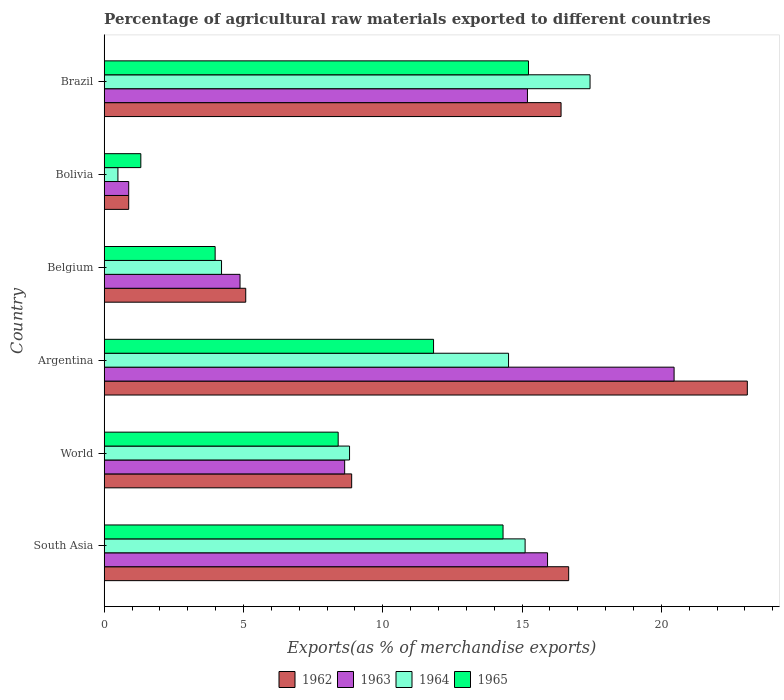How many different coloured bars are there?
Ensure brevity in your answer.  4. Are the number of bars on each tick of the Y-axis equal?
Keep it short and to the point. Yes. How many bars are there on the 6th tick from the top?
Your answer should be very brief. 4. How many bars are there on the 1st tick from the bottom?
Ensure brevity in your answer.  4. What is the label of the 6th group of bars from the top?
Give a very brief answer. South Asia. What is the percentage of exports to different countries in 1964 in World?
Provide a short and direct response. 8.81. Across all countries, what is the maximum percentage of exports to different countries in 1965?
Keep it short and to the point. 15.23. Across all countries, what is the minimum percentage of exports to different countries in 1964?
Offer a very short reply. 0.49. In which country was the percentage of exports to different countries in 1963 minimum?
Your answer should be compact. Bolivia. What is the total percentage of exports to different countries in 1963 in the graph?
Your answer should be compact. 65.96. What is the difference between the percentage of exports to different countries in 1964 in Bolivia and that in World?
Provide a succinct answer. -8.31. What is the difference between the percentage of exports to different countries in 1962 in South Asia and the percentage of exports to different countries in 1964 in Argentina?
Provide a succinct answer. 2.16. What is the average percentage of exports to different countries in 1962 per country?
Give a very brief answer. 11.84. What is the difference between the percentage of exports to different countries in 1963 and percentage of exports to different countries in 1964 in Brazil?
Offer a terse response. -2.25. In how many countries, is the percentage of exports to different countries in 1964 greater than 6 %?
Offer a very short reply. 4. What is the ratio of the percentage of exports to different countries in 1963 in Argentina to that in Bolivia?
Keep it short and to the point. 23.21. Is the difference between the percentage of exports to different countries in 1963 in Argentina and Belgium greater than the difference between the percentage of exports to different countries in 1964 in Argentina and Belgium?
Offer a very short reply. Yes. What is the difference between the highest and the second highest percentage of exports to different countries in 1963?
Provide a short and direct response. 4.54. What is the difference between the highest and the lowest percentage of exports to different countries in 1963?
Your answer should be compact. 19.58. In how many countries, is the percentage of exports to different countries in 1964 greater than the average percentage of exports to different countries in 1964 taken over all countries?
Offer a very short reply. 3. Is the sum of the percentage of exports to different countries in 1962 in Argentina and World greater than the maximum percentage of exports to different countries in 1964 across all countries?
Offer a very short reply. Yes. Is it the case that in every country, the sum of the percentage of exports to different countries in 1962 and percentage of exports to different countries in 1963 is greater than the sum of percentage of exports to different countries in 1964 and percentage of exports to different countries in 1965?
Offer a very short reply. No. What does the 2nd bar from the top in South Asia represents?
Ensure brevity in your answer.  1964. What does the 3rd bar from the bottom in South Asia represents?
Give a very brief answer. 1964. Is it the case that in every country, the sum of the percentage of exports to different countries in 1965 and percentage of exports to different countries in 1964 is greater than the percentage of exports to different countries in 1963?
Keep it short and to the point. Yes. What is the difference between two consecutive major ticks on the X-axis?
Your response must be concise. 5. Does the graph contain any zero values?
Give a very brief answer. No. Does the graph contain grids?
Your answer should be very brief. No. How are the legend labels stacked?
Give a very brief answer. Horizontal. What is the title of the graph?
Make the answer very short. Percentage of agricultural raw materials exported to different countries. What is the label or title of the X-axis?
Your answer should be very brief. Exports(as % of merchandise exports). What is the label or title of the Y-axis?
Provide a short and direct response. Country. What is the Exports(as % of merchandise exports) in 1962 in South Asia?
Provide a succinct answer. 16.67. What is the Exports(as % of merchandise exports) in 1963 in South Asia?
Your answer should be compact. 15.92. What is the Exports(as % of merchandise exports) in 1964 in South Asia?
Your answer should be very brief. 15.11. What is the Exports(as % of merchandise exports) of 1965 in South Asia?
Your answer should be very brief. 14.32. What is the Exports(as % of merchandise exports) of 1962 in World?
Ensure brevity in your answer.  8.89. What is the Exports(as % of merchandise exports) in 1963 in World?
Ensure brevity in your answer.  8.63. What is the Exports(as % of merchandise exports) in 1964 in World?
Ensure brevity in your answer.  8.81. What is the Exports(as % of merchandise exports) in 1965 in World?
Your answer should be compact. 8.4. What is the Exports(as % of merchandise exports) of 1962 in Argentina?
Keep it short and to the point. 23.09. What is the Exports(as % of merchandise exports) of 1963 in Argentina?
Provide a succinct answer. 20.46. What is the Exports(as % of merchandise exports) in 1964 in Argentina?
Provide a short and direct response. 14.52. What is the Exports(as % of merchandise exports) in 1965 in Argentina?
Provide a succinct answer. 11.82. What is the Exports(as % of merchandise exports) of 1962 in Belgium?
Your response must be concise. 5.08. What is the Exports(as % of merchandise exports) of 1963 in Belgium?
Make the answer very short. 4.88. What is the Exports(as % of merchandise exports) in 1964 in Belgium?
Your answer should be very brief. 4.21. What is the Exports(as % of merchandise exports) in 1965 in Belgium?
Your response must be concise. 3.98. What is the Exports(as % of merchandise exports) in 1962 in Bolivia?
Your response must be concise. 0.88. What is the Exports(as % of merchandise exports) of 1963 in Bolivia?
Your answer should be very brief. 0.88. What is the Exports(as % of merchandise exports) of 1964 in Bolivia?
Give a very brief answer. 0.49. What is the Exports(as % of merchandise exports) in 1965 in Bolivia?
Provide a short and direct response. 1.32. What is the Exports(as % of merchandise exports) of 1962 in Brazil?
Make the answer very short. 16.4. What is the Exports(as % of merchandise exports) in 1963 in Brazil?
Give a very brief answer. 15.2. What is the Exports(as % of merchandise exports) in 1964 in Brazil?
Your answer should be compact. 17.44. What is the Exports(as % of merchandise exports) in 1965 in Brazil?
Your answer should be compact. 15.23. Across all countries, what is the maximum Exports(as % of merchandise exports) in 1962?
Ensure brevity in your answer.  23.09. Across all countries, what is the maximum Exports(as % of merchandise exports) in 1963?
Your answer should be compact. 20.46. Across all countries, what is the maximum Exports(as % of merchandise exports) of 1964?
Your answer should be compact. 17.44. Across all countries, what is the maximum Exports(as % of merchandise exports) of 1965?
Your answer should be very brief. 15.23. Across all countries, what is the minimum Exports(as % of merchandise exports) of 1962?
Provide a short and direct response. 0.88. Across all countries, what is the minimum Exports(as % of merchandise exports) in 1963?
Keep it short and to the point. 0.88. Across all countries, what is the minimum Exports(as % of merchandise exports) of 1964?
Provide a succinct answer. 0.49. Across all countries, what is the minimum Exports(as % of merchandise exports) of 1965?
Provide a short and direct response. 1.32. What is the total Exports(as % of merchandise exports) of 1962 in the graph?
Keep it short and to the point. 71.01. What is the total Exports(as % of merchandise exports) in 1963 in the graph?
Give a very brief answer. 65.96. What is the total Exports(as % of merchandise exports) of 1964 in the graph?
Provide a succinct answer. 60.59. What is the total Exports(as % of merchandise exports) in 1965 in the graph?
Your answer should be compact. 55.08. What is the difference between the Exports(as % of merchandise exports) in 1962 in South Asia and that in World?
Your answer should be compact. 7.79. What is the difference between the Exports(as % of merchandise exports) in 1963 in South Asia and that in World?
Make the answer very short. 7.28. What is the difference between the Exports(as % of merchandise exports) in 1964 in South Asia and that in World?
Give a very brief answer. 6.3. What is the difference between the Exports(as % of merchandise exports) of 1965 in South Asia and that in World?
Ensure brevity in your answer.  5.92. What is the difference between the Exports(as % of merchandise exports) in 1962 in South Asia and that in Argentina?
Your answer should be compact. -6.41. What is the difference between the Exports(as % of merchandise exports) of 1963 in South Asia and that in Argentina?
Keep it short and to the point. -4.54. What is the difference between the Exports(as % of merchandise exports) of 1964 in South Asia and that in Argentina?
Offer a very short reply. 0.59. What is the difference between the Exports(as % of merchandise exports) of 1965 in South Asia and that in Argentina?
Keep it short and to the point. 2.49. What is the difference between the Exports(as % of merchandise exports) of 1962 in South Asia and that in Belgium?
Offer a very short reply. 11.59. What is the difference between the Exports(as % of merchandise exports) in 1963 in South Asia and that in Belgium?
Offer a terse response. 11.04. What is the difference between the Exports(as % of merchandise exports) of 1964 in South Asia and that in Belgium?
Offer a very short reply. 10.9. What is the difference between the Exports(as % of merchandise exports) in 1965 in South Asia and that in Belgium?
Offer a terse response. 10.34. What is the difference between the Exports(as % of merchandise exports) of 1962 in South Asia and that in Bolivia?
Your answer should be very brief. 15.79. What is the difference between the Exports(as % of merchandise exports) in 1963 in South Asia and that in Bolivia?
Provide a short and direct response. 15.03. What is the difference between the Exports(as % of merchandise exports) in 1964 in South Asia and that in Bolivia?
Offer a terse response. 14.62. What is the difference between the Exports(as % of merchandise exports) in 1965 in South Asia and that in Bolivia?
Offer a very short reply. 13. What is the difference between the Exports(as % of merchandise exports) in 1962 in South Asia and that in Brazil?
Make the answer very short. 0.27. What is the difference between the Exports(as % of merchandise exports) in 1963 in South Asia and that in Brazil?
Provide a succinct answer. 0.72. What is the difference between the Exports(as % of merchandise exports) of 1964 in South Asia and that in Brazil?
Provide a short and direct response. -2.33. What is the difference between the Exports(as % of merchandise exports) of 1965 in South Asia and that in Brazil?
Your response must be concise. -0.91. What is the difference between the Exports(as % of merchandise exports) in 1962 in World and that in Argentina?
Make the answer very short. -14.2. What is the difference between the Exports(as % of merchandise exports) in 1963 in World and that in Argentina?
Your answer should be very brief. -11.83. What is the difference between the Exports(as % of merchandise exports) in 1964 in World and that in Argentina?
Offer a terse response. -5.71. What is the difference between the Exports(as % of merchandise exports) of 1965 in World and that in Argentina?
Your answer should be compact. -3.42. What is the difference between the Exports(as % of merchandise exports) of 1962 in World and that in Belgium?
Give a very brief answer. 3.8. What is the difference between the Exports(as % of merchandise exports) in 1963 in World and that in Belgium?
Provide a short and direct response. 3.76. What is the difference between the Exports(as % of merchandise exports) of 1964 in World and that in Belgium?
Offer a very short reply. 4.6. What is the difference between the Exports(as % of merchandise exports) in 1965 in World and that in Belgium?
Ensure brevity in your answer.  4.42. What is the difference between the Exports(as % of merchandise exports) of 1962 in World and that in Bolivia?
Your answer should be very brief. 8. What is the difference between the Exports(as % of merchandise exports) in 1963 in World and that in Bolivia?
Your answer should be very brief. 7.75. What is the difference between the Exports(as % of merchandise exports) in 1964 in World and that in Bolivia?
Ensure brevity in your answer.  8.31. What is the difference between the Exports(as % of merchandise exports) of 1965 in World and that in Bolivia?
Offer a very short reply. 7.08. What is the difference between the Exports(as % of merchandise exports) in 1962 in World and that in Brazil?
Provide a short and direct response. -7.52. What is the difference between the Exports(as % of merchandise exports) in 1963 in World and that in Brazil?
Provide a succinct answer. -6.56. What is the difference between the Exports(as % of merchandise exports) of 1964 in World and that in Brazil?
Offer a very short reply. -8.63. What is the difference between the Exports(as % of merchandise exports) in 1965 in World and that in Brazil?
Ensure brevity in your answer.  -6.83. What is the difference between the Exports(as % of merchandise exports) in 1962 in Argentina and that in Belgium?
Provide a short and direct response. 18.01. What is the difference between the Exports(as % of merchandise exports) of 1963 in Argentina and that in Belgium?
Offer a terse response. 15.58. What is the difference between the Exports(as % of merchandise exports) in 1964 in Argentina and that in Belgium?
Your answer should be very brief. 10.3. What is the difference between the Exports(as % of merchandise exports) of 1965 in Argentina and that in Belgium?
Provide a short and direct response. 7.84. What is the difference between the Exports(as % of merchandise exports) in 1962 in Argentina and that in Bolivia?
Your response must be concise. 22.21. What is the difference between the Exports(as % of merchandise exports) of 1963 in Argentina and that in Bolivia?
Offer a very short reply. 19.58. What is the difference between the Exports(as % of merchandise exports) of 1964 in Argentina and that in Bolivia?
Provide a succinct answer. 14.02. What is the difference between the Exports(as % of merchandise exports) of 1965 in Argentina and that in Bolivia?
Give a very brief answer. 10.51. What is the difference between the Exports(as % of merchandise exports) in 1962 in Argentina and that in Brazil?
Make the answer very short. 6.69. What is the difference between the Exports(as % of merchandise exports) in 1963 in Argentina and that in Brazil?
Ensure brevity in your answer.  5.26. What is the difference between the Exports(as % of merchandise exports) in 1964 in Argentina and that in Brazil?
Your answer should be compact. -2.93. What is the difference between the Exports(as % of merchandise exports) in 1965 in Argentina and that in Brazil?
Give a very brief answer. -3.41. What is the difference between the Exports(as % of merchandise exports) of 1962 in Belgium and that in Bolivia?
Provide a short and direct response. 4.2. What is the difference between the Exports(as % of merchandise exports) of 1963 in Belgium and that in Bolivia?
Your response must be concise. 4. What is the difference between the Exports(as % of merchandise exports) in 1964 in Belgium and that in Bolivia?
Your answer should be very brief. 3.72. What is the difference between the Exports(as % of merchandise exports) in 1965 in Belgium and that in Bolivia?
Ensure brevity in your answer.  2.67. What is the difference between the Exports(as % of merchandise exports) in 1962 in Belgium and that in Brazil?
Offer a terse response. -11.32. What is the difference between the Exports(as % of merchandise exports) of 1963 in Belgium and that in Brazil?
Give a very brief answer. -10.32. What is the difference between the Exports(as % of merchandise exports) of 1964 in Belgium and that in Brazil?
Give a very brief answer. -13.23. What is the difference between the Exports(as % of merchandise exports) of 1965 in Belgium and that in Brazil?
Your response must be concise. -11.25. What is the difference between the Exports(as % of merchandise exports) of 1962 in Bolivia and that in Brazil?
Give a very brief answer. -15.52. What is the difference between the Exports(as % of merchandise exports) of 1963 in Bolivia and that in Brazil?
Make the answer very short. -14.31. What is the difference between the Exports(as % of merchandise exports) of 1964 in Bolivia and that in Brazil?
Give a very brief answer. -16.95. What is the difference between the Exports(as % of merchandise exports) in 1965 in Bolivia and that in Brazil?
Provide a short and direct response. -13.92. What is the difference between the Exports(as % of merchandise exports) of 1962 in South Asia and the Exports(as % of merchandise exports) of 1963 in World?
Your answer should be very brief. 8.04. What is the difference between the Exports(as % of merchandise exports) in 1962 in South Asia and the Exports(as % of merchandise exports) in 1964 in World?
Your response must be concise. 7.87. What is the difference between the Exports(as % of merchandise exports) of 1962 in South Asia and the Exports(as % of merchandise exports) of 1965 in World?
Offer a terse response. 8.27. What is the difference between the Exports(as % of merchandise exports) in 1963 in South Asia and the Exports(as % of merchandise exports) in 1964 in World?
Make the answer very short. 7.11. What is the difference between the Exports(as % of merchandise exports) in 1963 in South Asia and the Exports(as % of merchandise exports) in 1965 in World?
Ensure brevity in your answer.  7.52. What is the difference between the Exports(as % of merchandise exports) of 1964 in South Asia and the Exports(as % of merchandise exports) of 1965 in World?
Offer a very short reply. 6.71. What is the difference between the Exports(as % of merchandise exports) of 1962 in South Asia and the Exports(as % of merchandise exports) of 1963 in Argentina?
Provide a succinct answer. -3.78. What is the difference between the Exports(as % of merchandise exports) in 1962 in South Asia and the Exports(as % of merchandise exports) in 1964 in Argentina?
Give a very brief answer. 2.16. What is the difference between the Exports(as % of merchandise exports) of 1962 in South Asia and the Exports(as % of merchandise exports) of 1965 in Argentina?
Offer a very short reply. 4.85. What is the difference between the Exports(as % of merchandise exports) in 1963 in South Asia and the Exports(as % of merchandise exports) in 1964 in Argentina?
Give a very brief answer. 1.4. What is the difference between the Exports(as % of merchandise exports) in 1963 in South Asia and the Exports(as % of merchandise exports) in 1965 in Argentina?
Offer a very short reply. 4.09. What is the difference between the Exports(as % of merchandise exports) in 1964 in South Asia and the Exports(as % of merchandise exports) in 1965 in Argentina?
Your answer should be compact. 3.29. What is the difference between the Exports(as % of merchandise exports) in 1962 in South Asia and the Exports(as % of merchandise exports) in 1963 in Belgium?
Ensure brevity in your answer.  11.8. What is the difference between the Exports(as % of merchandise exports) of 1962 in South Asia and the Exports(as % of merchandise exports) of 1964 in Belgium?
Your answer should be very brief. 12.46. What is the difference between the Exports(as % of merchandise exports) in 1962 in South Asia and the Exports(as % of merchandise exports) in 1965 in Belgium?
Your answer should be compact. 12.69. What is the difference between the Exports(as % of merchandise exports) in 1963 in South Asia and the Exports(as % of merchandise exports) in 1964 in Belgium?
Your answer should be compact. 11.7. What is the difference between the Exports(as % of merchandise exports) in 1963 in South Asia and the Exports(as % of merchandise exports) in 1965 in Belgium?
Offer a terse response. 11.93. What is the difference between the Exports(as % of merchandise exports) of 1964 in South Asia and the Exports(as % of merchandise exports) of 1965 in Belgium?
Offer a very short reply. 11.13. What is the difference between the Exports(as % of merchandise exports) in 1962 in South Asia and the Exports(as % of merchandise exports) in 1963 in Bolivia?
Provide a succinct answer. 15.79. What is the difference between the Exports(as % of merchandise exports) in 1962 in South Asia and the Exports(as % of merchandise exports) in 1964 in Bolivia?
Your answer should be compact. 16.18. What is the difference between the Exports(as % of merchandise exports) in 1962 in South Asia and the Exports(as % of merchandise exports) in 1965 in Bolivia?
Your response must be concise. 15.36. What is the difference between the Exports(as % of merchandise exports) of 1963 in South Asia and the Exports(as % of merchandise exports) of 1964 in Bolivia?
Offer a very short reply. 15.42. What is the difference between the Exports(as % of merchandise exports) of 1963 in South Asia and the Exports(as % of merchandise exports) of 1965 in Bolivia?
Your answer should be very brief. 14.6. What is the difference between the Exports(as % of merchandise exports) in 1964 in South Asia and the Exports(as % of merchandise exports) in 1965 in Bolivia?
Ensure brevity in your answer.  13.79. What is the difference between the Exports(as % of merchandise exports) in 1962 in South Asia and the Exports(as % of merchandise exports) in 1963 in Brazil?
Offer a terse response. 1.48. What is the difference between the Exports(as % of merchandise exports) in 1962 in South Asia and the Exports(as % of merchandise exports) in 1964 in Brazil?
Give a very brief answer. -0.77. What is the difference between the Exports(as % of merchandise exports) of 1962 in South Asia and the Exports(as % of merchandise exports) of 1965 in Brazil?
Your answer should be compact. 1.44. What is the difference between the Exports(as % of merchandise exports) in 1963 in South Asia and the Exports(as % of merchandise exports) in 1964 in Brazil?
Provide a succinct answer. -1.53. What is the difference between the Exports(as % of merchandise exports) of 1963 in South Asia and the Exports(as % of merchandise exports) of 1965 in Brazil?
Keep it short and to the point. 0.68. What is the difference between the Exports(as % of merchandise exports) of 1964 in South Asia and the Exports(as % of merchandise exports) of 1965 in Brazil?
Keep it short and to the point. -0.12. What is the difference between the Exports(as % of merchandise exports) of 1962 in World and the Exports(as % of merchandise exports) of 1963 in Argentina?
Offer a very short reply. -11.57. What is the difference between the Exports(as % of merchandise exports) in 1962 in World and the Exports(as % of merchandise exports) in 1964 in Argentina?
Offer a terse response. -5.63. What is the difference between the Exports(as % of merchandise exports) in 1962 in World and the Exports(as % of merchandise exports) in 1965 in Argentina?
Your answer should be very brief. -2.94. What is the difference between the Exports(as % of merchandise exports) of 1963 in World and the Exports(as % of merchandise exports) of 1964 in Argentina?
Your response must be concise. -5.88. What is the difference between the Exports(as % of merchandise exports) of 1963 in World and the Exports(as % of merchandise exports) of 1965 in Argentina?
Provide a succinct answer. -3.19. What is the difference between the Exports(as % of merchandise exports) of 1964 in World and the Exports(as % of merchandise exports) of 1965 in Argentina?
Your answer should be compact. -3.02. What is the difference between the Exports(as % of merchandise exports) of 1962 in World and the Exports(as % of merchandise exports) of 1963 in Belgium?
Offer a very short reply. 4.01. What is the difference between the Exports(as % of merchandise exports) in 1962 in World and the Exports(as % of merchandise exports) in 1964 in Belgium?
Provide a succinct answer. 4.67. What is the difference between the Exports(as % of merchandise exports) of 1962 in World and the Exports(as % of merchandise exports) of 1965 in Belgium?
Make the answer very short. 4.9. What is the difference between the Exports(as % of merchandise exports) in 1963 in World and the Exports(as % of merchandise exports) in 1964 in Belgium?
Your answer should be very brief. 4.42. What is the difference between the Exports(as % of merchandise exports) in 1963 in World and the Exports(as % of merchandise exports) in 1965 in Belgium?
Give a very brief answer. 4.65. What is the difference between the Exports(as % of merchandise exports) of 1964 in World and the Exports(as % of merchandise exports) of 1965 in Belgium?
Your answer should be compact. 4.82. What is the difference between the Exports(as % of merchandise exports) in 1962 in World and the Exports(as % of merchandise exports) in 1963 in Bolivia?
Provide a short and direct response. 8. What is the difference between the Exports(as % of merchandise exports) in 1962 in World and the Exports(as % of merchandise exports) in 1964 in Bolivia?
Offer a terse response. 8.39. What is the difference between the Exports(as % of merchandise exports) in 1962 in World and the Exports(as % of merchandise exports) in 1965 in Bolivia?
Provide a short and direct response. 7.57. What is the difference between the Exports(as % of merchandise exports) of 1963 in World and the Exports(as % of merchandise exports) of 1964 in Bolivia?
Keep it short and to the point. 8.14. What is the difference between the Exports(as % of merchandise exports) in 1963 in World and the Exports(as % of merchandise exports) in 1965 in Bolivia?
Ensure brevity in your answer.  7.32. What is the difference between the Exports(as % of merchandise exports) of 1964 in World and the Exports(as % of merchandise exports) of 1965 in Bolivia?
Your answer should be very brief. 7.49. What is the difference between the Exports(as % of merchandise exports) in 1962 in World and the Exports(as % of merchandise exports) in 1963 in Brazil?
Make the answer very short. -6.31. What is the difference between the Exports(as % of merchandise exports) in 1962 in World and the Exports(as % of merchandise exports) in 1964 in Brazil?
Your answer should be very brief. -8.56. What is the difference between the Exports(as % of merchandise exports) of 1962 in World and the Exports(as % of merchandise exports) of 1965 in Brazil?
Provide a short and direct response. -6.35. What is the difference between the Exports(as % of merchandise exports) in 1963 in World and the Exports(as % of merchandise exports) in 1964 in Brazil?
Keep it short and to the point. -8.81. What is the difference between the Exports(as % of merchandise exports) in 1963 in World and the Exports(as % of merchandise exports) in 1965 in Brazil?
Keep it short and to the point. -6.6. What is the difference between the Exports(as % of merchandise exports) of 1964 in World and the Exports(as % of merchandise exports) of 1965 in Brazil?
Provide a short and direct response. -6.42. What is the difference between the Exports(as % of merchandise exports) of 1962 in Argentina and the Exports(as % of merchandise exports) of 1963 in Belgium?
Your answer should be compact. 18.21. What is the difference between the Exports(as % of merchandise exports) in 1962 in Argentina and the Exports(as % of merchandise exports) in 1964 in Belgium?
Your answer should be compact. 18.87. What is the difference between the Exports(as % of merchandise exports) of 1962 in Argentina and the Exports(as % of merchandise exports) of 1965 in Belgium?
Offer a very short reply. 19.1. What is the difference between the Exports(as % of merchandise exports) in 1963 in Argentina and the Exports(as % of merchandise exports) in 1964 in Belgium?
Your answer should be compact. 16.25. What is the difference between the Exports(as % of merchandise exports) of 1963 in Argentina and the Exports(as % of merchandise exports) of 1965 in Belgium?
Ensure brevity in your answer.  16.48. What is the difference between the Exports(as % of merchandise exports) of 1964 in Argentina and the Exports(as % of merchandise exports) of 1965 in Belgium?
Keep it short and to the point. 10.53. What is the difference between the Exports(as % of merchandise exports) of 1962 in Argentina and the Exports(as % of merchandise exports) of 1963 in Bolivia?
Give a very brief answer. 22.21. What is the difference between the Exports(as % of merchandise exports) of 1962 in Argentina and the Exports(as % of merchandise exports) of 1964 in Bolivia?
Ensure brevity in your answer.  22.59. What is the difference between the Exports(as % of merchandise exports) in 1962 in Argentina and the Exports(as % of merchandise exports) in 1965 in Bolivia?
Your answer should be compact. 21.77. What is the difference between the Exports(as % of merchandise exports) of 1963 in Argentina and the Exports(as % of merchandise exports) of 1964 in Bolivia?
Give a very brief answer. 19.96. What is the difference between the Exports(as % of merchandise exports) in 1963 in Argentina and the Exports(as % of merchandise exports) in 1965 in Bolivia?
Offer a very short reply. 19.14. What is the difference between the Exports(as % of merchandise exports) of 1964 in Argentina and the Exports(as % of merchandise exports) of 1965 in Bolivia?
Your response must be concise. 13.2. What is the difference between the Exports(as % of merchandise exports) of 1962 in Argentina and the Exports(as % of merchandise exports) of 1963 in Brazil?
Offer a terse response. 7.89. What is the difference between the Exports(as % of merchandise exports) of 1962 in Argentina and the Exports(as % of merchandise exports) of 1964 in Brazil?
Keep it short and to the point. 5.65. What is the difference between the Exports(as % of merchandise exports) in 1962 in Argentina and the Exports(as % of merchandise exports) in 1965 in Brazil?
Give a very brief answer. 7.86. What is the difference between the Exports(as % of merchandise exports) of 1963 in Argentina and the Exports(as % of merchandise exports) of 1964 in Brazil?
Your response must be concise. 3.02. What is the difference between the Exports(as % of merchandise exports) in 1963 in Argentina and the Exports(as % of merchandise exports) in 1965 in Brazil?
Offer a terse response. 5.23. What is the difference between the Exports(as % of merchandise exports) in 1964 in Argentina and the Exports(as % of merchandise exports) in 1965 in Brazil?
Your answer should be compact. -0.72. What is the difference between the Exports(as % of merchandise exports) in 1962 in Belgium and the Exports(as % of merchandise exports) in 1963 in Bolivia?
Ensure brevity in your answer.  4.2. What is the difference between the Exports(as % of merchandise exports) of 1962 in Belgium and the Exports(as % of merchandise exports) of 1964 in Bolivia?
Your answer should be compact. 4.59. What is the difference between the Exports(as % of merchandise exports) in 1962 in Belgium and the Exports(as % of merchandise exports) in 1965 in Bolivia?
Keep it short and to the point. 3.77. What is the difference between the Exports(as % of merchandise exports) of 1963 in Belgium and the Exports(as % of merchandise exports) of 1964 in Bolivia?
Ensure brevity in your answer.  4.38. What is the difference between the Exports(as % of merchandise exports) in 1963 in Belgium and the Exports(as % of merchandise exports) in 1965 in Bolivia?
Keep it short and to the point. 3.56. What is the difference between the Exports(as % of merchandise exports) in 1964 in Belgium and the Exports(as % of merchandise exports) in 1965 in Bolivia?
Offer a very short reply. 2.9. What is the difference between the Exports(as % of merchandise exports) of 1962 in Belgium and the Exports(as % of merchandise exports) of 1963 in Brazil?
Ensure brevity in your answer.  -10.11. What is the difference between the Exports(as % of merchandise exports) in 1962 in Belgium and the Exports(as % of merchandise exports) in 1964 in Brazil?
Provide a succinct answer. -12.36. What is the difference between the Exports(as % of merchandise exports) of 1962 in Belgium and the Exports(as % of merchandise exports) of 1965 in Brazil?
Keep it short and to the point. -10.15. What is the difference between the Exports(as % of merchandise exports) of 1963 in Belgium and the Exports(as % of merchandise exports) of 1964 in Brazil?
Ensure brevity in your answer.  -12.56. What is the difference between the Exports(as % of merchandise exports) in 1963 in Belgium and the Exports(as % of merchandise exports) in 1965 in Brazil?
Make the answer very short. -10.35. What is the difference between the Exports(as % of merchandise exports) in 1964 in Belgium and the Exports(as % of merchandise exports) in 1965 in Brazil?
Provide a succinct answer. -11.02. What is the difference between the Exports(as % of merchandise exports) of 1962 in Bolivia and the Exports(as % of merchandise exports) of 1963 in Brazil?
Make the answer very short. -14.31. What is the difference between the Exports(as % of merchandise exports) in 1962 in Bolivia and the Exports(as % of merchandise exports) in 1964 in Brazil?
Provide a short and direct response. -16.56. What is the difference between the Exports(as % of merchandise exports) of 1962 in Bolivia and the Exports(as % of merchandise exports) of 1965 in Brazil?
Provide a short and direct response. -14.35. What is the difference between the Exports(as % of merchandise exports) of 1963 in Bolivia and the Exports(as % of merchandise exports) of 1964 in Brazil?
Your answer should be compact. -16.56. What is the difference between the Exports(as % of merchandise exports) in 1963 in Bolivia and the Exports(as % of merchandise exports) in 1965 in Brazil?
Offer a terse response. -14.35. What is the difference between the Exports(as % of merchandise exports) of 1964 in Bolivia and the Exports(as % of merchandise exports) of 1965 in Brazil?
Ensure brevity in your answer.  -14.74. What is the average Exports(as % of merchandise exports) of 1962 per country?
Give a very brief answer. 11.84. What is the average Exports(as % of merchandise exports) in 1963 per country?
Your answer should be very brief. 10.99. What is the average Exports(as % of merchandise exports) of 1964 per country?
Offer a terse response. 10.1. What is the average Exports(as % of merchandise exports) in 1965 per country?
Your answer should be very brief. 9.18. What is the difference between the Exports(as % of merchandise exports) of 1962 and Exports(as % of merchandise exports) of 1963 in South Asia?
Ensure brevity in your answer.  0.76. What is the difference between the Exports(as % of merchandise exports) in 1962 and Exports(as % of merchandise exports) in 1964 in South Asia?
Provide a succinct answer. 1.56. What is the difference between the Exports(as % of merchandise exports) in 1962 and Exports(as % of merchandise exports) in 1965 in South Asia?
Give a very brief answer. 2.36. What is the difference between the Exports(as % of merchandise exports) of 1963 and Exports(as % of merchandise exports) of 1964 in South Asia?
Ensure brevity in your answer.  0.81. What is the difference between the Exports(as % of merchandise exports) in 1963 and Exports(as % of merchandise exports) in 1965 in South Asia?
Provide a succinct answer. 1.6. What is the difference between the Exports(as % of merchandise exports) of 1964 and Exports(as % of merchandise exports) of 1965 in South Asia?
Give a very brief answer. 0.79. What is the difference between the Exports(as % of merchandise exports) of 1962 and Exports(as % of merchandise exports) of 1963 in World?
Ensure brevity in your answer.  0.25. What is the difference between the Exports(as % of merchandise exports) of 1962 and Exports(as % of merchandise exports) of 1964 in World?
Keep it short and to the point. 0.08. What is the difference between the Exports(as % of merchandise exports) of 1962 and Exports(as % of merchandise exports) of 1965 in World?
Offer a very short reply. 0.48. What is the difference between the Exports(as % of merchandise exports) in 1963 and Exports(as % of merchandise exports) in 1964 in World?
Your answer should be very brief. -0.18. What is the difference between the Exports(as % of merchandise exports) in 1963 and Exports(as % of merchandise exports) in 1965 in World?
Offer a very short reply. 0.23. What is the difference between the Exports(as % of merchandise exports) of 1964 and Exports(as % of merchandise exports) of 1965 in World?
Your answer should be very brief. 0.41. What is the difference between the Exports(as % of merchandise exports) of 1962 and Exports(as % of merchandise exports) of 1963 in Argentina?
Your answer should be compact. 2.63. What is the difference between the Exports(as % of merchandise exports) of 1962 and Exports(as % of merchandise exports) of 1964 in Argentina?
Give a very brief answer. 8.57. What is the difference between the Exports(as % of merchandise exports) of 1962 and Exports(as % of merchandise exports) of 1965 in Argentina?
Offer a terse response. 11.26. What is the difference between the Exports(as % of merchandise exports) in 1963 and Exports(as % of merchandise exports) in 1964 in Argentina?
Make the answer very short. 5.94. What is the difference between the Exports(as % of merchandise exports) of 1963 and Exports(as % of merchandise exports) of 1965 in Argentina?
Your answer should be compact. 8.63. What is the difference between the Exports(as % of merchandise exports) in 1964 and Exports(as % of merchandise exports) in 1965 in Argentina?
Your answer should be very brief. 2.69. What is the difference between the Exports(as % of merchandise exports) in 1962 and Exports(as % of merchandise exports) in 1963 in Belgium?
Provide a succinct answer. 0.2. What is the difference between the Exports(as % of merchandise exports) of 1962 and Exports(as % of merchandise exports) of 1964 in Belgium?
Ensure brevity in your answer.  0.87. What is the difference between the Exports(as % of merchandise exports) in 1962 and Exports(as % of merchandise exports) in 1965 in Belgium?
Ensure brevity in your answer.  1.1. What is the difference between the Exports(as % of merchandise exports) of 1963 and Exports(as % of merchandise exports) of 1964 in Belgium?
Offer a very short reply. 0.66. What is the difference between the Exports(as % of merchandise exports) of 1963 and Exports(as % of merchandise exports) of 1965 in Belgium?
Keep it short and to the point. 0.89. What is the difference between the Exports(as % of merchandise exports) of 1964 and Exports(as % of merchandise exports) of 1965 in Belgium?
Your answer should be very brief. 0.23. What is the difference between the Exports(as % of merchandise exports) in 1962 and Exports(as % of merchandise exports) in 1963 in Bolivia?
Provide a short and direct response. 0. What is the difference between the Exports(as % of merchandise exports) in 1962 and Exports(as % of merchandise exports) in 1964 in Bolivia?
Give a very brief answer. 0.39. What is the difference between the Exports(as % of merchandise exports) in 1962 and Exports(as % of merchandise exports) in 1965 in Bolivia?
Your answer should be compact. -0.43. What is the difference between the Exports(as % of merchandise exports) in 1963 and Exports(as % of merchandise exports) in 1964 in Bolivia?
Give a very brief answer. 0.39. What is the difference between the Exports(as % of merchandise exports) of 1963 and Exports(as % of merchandise exports) of 1965 in Bolivia?
Offer a very short reply. -0.43. What is the difference between the Exports(as % of merchandise exports) in 1964 and Exports(as % of merchandise exports) in 1965 in Bolivia?
Give a very brief answer. -0.82. What is the difference between the Exports(as % of merchandise exports) of 1962 and Exports(as % of merchandise exports) of 1963 in Brazil?
Your answer should be very brief. 1.21. What is the difference between the Exports(as % of merchandise exports) in 1962 and Exports(as % of merchandise exports) in 1964 in Brazil?
Ensure brevity in your answer.  -1.04. What is the difference between the Exports(as % of merchandise exports) in 1962 and Exports(as % of merchandise exports) in 1965 in Brazil?
Your response must be concise. 1.17. What is the difference between the Exports(as % of merchandise exports) of 1963 and Exports(as % of merchandise exports) of 1964 in Brazil?
Your answer should be compact. -2.25. What is the difference between the Exports(as % of merchandise exports) of 1963 and Exports(as % of merchandise exports) of 1965 in Brazil?
Ensure brevity in your answer.  -0.04. What is the difference between the Exports(as % of merchandise exports) of 1964 and Exports(as % of merchandise exports) of 1965 in Brazil?
Offer a very short reply. 2.21. What is the ratio of the Exports(as % of merchandise exports) in 1962 in South Asia to that in World?
Your answer should be very brief. 1.88. What is the ratio of the Exports(as % of merchandise exports) in 1963 in South Asia to that in World?
Provide a succinct answer. 1.84. What is the ratio of the Exports(as % of merchandise exports) of 1964 in South Asia to that in World?
Offer a terse response. 1.72. What is the ratio of the Exports(as % of merchandise exports) in 1965 in South Asia to that in World?
Keep it short and to the point. 1.7. What is the ratio of the Exports(as % of merchandise exports) in 1962 in South Asia to that in Argentina?
Your response must be concise. 0.72. What is the ratio of the Exports(as % of merchandise exports) of 1963 in South Asia to that in Argentina?
Make the answer very short. 0.78. What is the ratio of the Exports(as % of merchandise exports) in 1964 in South Asia to that in Argentina?
Keep it short and to the point. 1.04. What is the ratio of the Exports(as % of merchandise exports) in 1965 in South Asia to that in Argentina?
Offer a very short reply. 1.21. What is the ratio of the Exports(as % of merchandise exports) in 1962 in South Asia to that in Belgium?
Provide a short and direct response. 3.28. What is the ratio of the Exports(as % of merchandise exports) in 1963 in South Asia to that in Belgium?
Your response must be concise. 3.26. What is the ratio of the Exports(as % of merchandise exports) in 1964 in South Asia to that in Belgium?
Provide a short and direct response. 3.59. What is the ratio of the Exports(as % of merchandise exports) of 1965 in South Asia to that in Belgium?
Your response must be concise. 3.59. What is the ratio of the Exports(as % of merchandise exports) of 1962 in South Asia to that in Bolivia?
Your answer should be compact. 18.92. What is the ratio of the Exports(as % of merchandise exports) of 1963 in South Asia to that in Bolivia?
Offer a terse response. 18.06. What is the ratio of the Exports(as % of merchandise exports) of 1964 in South Asia to that in Bolivia?
Your response must be concise. 30.56. What is the ratio of the Exports(as % of merchandise exports) in 1965 in South Asia to that in Bolivia?
Ensure brevity in your answer.  10.88. What is the ratio of the Exports(as % of merchandise exports) in 1962 in South Asia to that in Brazil?
Your answer should be compact. 1.02. What is the ratio of the Exports(as % of merchandise exports) of 1963 in South Asia to that in Brazil?
Your answer should be compact. 1.05. What is the ratio of the Exports(as % of merchandise exports) of 1964 in South Asia to that in Brazil?
Give a very brief answer. 0.87. What is the ratio of the Exports(as % of merchandise exports) in 1965 in South Asia to that in Brazil?
Give a very brief answer. 0.94. What is the ratio of the Exports(as % of merchandise exports) in 1962 in World to that in Argentina?
Ensure brevity in your answer.  0.38. What is the ratio of the Exports(as % of merchandise exports) in 1963 in World to that in Argentina?
Keep it short and to the point. 0.42. What is the ratio of the Exports(as % of merchandise exports) in 1964 in World to that in Argentina?
Offer a terse response. 0.61. What is the ratio of the Exports(as % of merchandise exports) in 1965 in World to that in Argentina?
Offer a terse response. 0.71. What is the ratio of the Exports(as % of merchandise exports) in 1962 in World to that in Belgium?
Give a very brief answer. 1.75. What is the ratio of the Exports(as % of merchandise exports) of 1963 in World to that in Belgium?
Your answer should be compact. 1.77. What is the ratio of the Exports(as % of merchandise exports) in 1964 in World to that in Belgium?
Your response must be concise. 2.09. What is the ratio of the Exports(as % of merchandise exports) in 1965 in World to that in Belgium?
Your answer should be very brief. 2.11. What is the ratio of the Exports(as % of merchandise exports) in 1962 in World to that in Bolivia?
Give a very brief answer. 10.08. What is the ratio of the Exports(as % of merchandise exports) in 1963 in World to that in Bolivia?
Your response must be concise. 9.79. What is the ratio of the Exports(as % of merchandise exports) of 1964 in World to that in Bolivia?
Make the answer very short. 17.82. What is the ratio of the Exports(as % of merchandise exports) in 1965 in World to that in Bolivia?
Make the answer very short. 6.38. What is the ratio of the Exports(as % of merchandise exports) of 1962 in World to that in Brazil?
Ensure brevity in your answer.  0.54. What is the ratio of the Exports(as % of merchandise exports) of 1963 in World to that in Brazil?
Your answer should be very brief. 0.57. What is the ratio of the Exports(as % of merchandise exports) in 1964 in World to that in Brazil?
Offer a terse response. 0.51. What is the ratio of the Exports(as % of merchandise exports) of 1965 in World to that in Brazil?
Your answer should be very brief. 0.55. What is the ratio of the Exports(as % of merchandise exports) of 1962 in Argentina to that in Belgium?
Provide a succinct answer. 4.54. What is the ratio of the Exports(as % of merchandise exports) of 1963 in Argentina to that in Belgium?
Your answer should be compact. 4.19. What is the ratio of the Exports(as % of merchandise exports) of 1964 in Argentina to that in Belgium?
Make the answer very short. 3.45. What is the ratio of the Exports(as % of merchandise exports) of 1965 in Argentina to that in Belgium?
Your answer should be compact. 2.97. What is the ratio of the Exports(as % of merchandise exports) in 1962 in Argentina to that in Bolivia?
Provide a succinct answer. 26.19. What is the ratio of the Exports(as % of merchandise exports) of 1963 in Argentina to that in Bolivia?
Offer a very short reply. 23.21. What is the ratio of the Exports(as % of merchandise exports) in 1964 in Argentina to that in Bolivia?
Give a very brief answer. 29.36. What is the ratio of the Exports(as % of merchandise exports) of 1965 in Argentina to that in Bolivia?
Provide a short and direct response. 8.98. What is the ratio of the Exports(as % of merchandise exports) of 1962 in Argentina to that in Brazil?
Offer a terse response. 1.41. What is the ratio of the Exports(as % of merchandise exports) in 1963 in Argentina to that in Brazil?
Provide a succinct answer. 1.35. What is the ratio of the Exports(as % of merchandise exports) in 1964 in Argentina to that in Brazil?
Your response must be concise. 0.83. What is the ratio of the Exports(as % of merchandise exports) in 1965 in Argentina to that in Brazil?
Make the answer very short. 0.78. What is the ratio of the Exports(as % of merchandise exports) in 1962 in Belgium to that in Bolivia?
Provide a succinct answer. 5.77. What is the ratio of the Exports(as % of merchandise exports) in 1963 in Belgium to that in Bolivia?
Your response must be concise. 5.53. What is the ratio of the Exports(as % of merchandise exports) of 1964 in Belgium to that in Bolivia?
Offer a terse response. 8.52. What is the ratio of the Exports(as % of merchandise exports) of 1965 in Belgium to that in Bolivia?
Offer a very short reply. 3.03. What is the ratio of the Exports(as % of merchandise exports) of 1962 in Belgium to that in Brazil?
Your answer should be very brief. 0.31. What is the ratio of the Exports(as % of merchandise exports) in 1963 in Belgium to that in Brazil?
Provide a short and direct response. 0.32. What is the ratio of the Exports(as % of merchandise exports) of 1964 in Belgium to that in Brazil?
Give a very brief answer. 0.24. What is the ratio of the Exports(as % of merchandise exports) in 1965 in Belgium to that in Brazil?
Keep it short and to the point. 0.26. What is the ratio of the Exports(as % of merchandise exports) in 1962 in Bolivia to that in Brazil?
Your answer should be compact. 0.05. What is the ratio of the Exports(as % of merchandise exports) in 1963 in Bolivia to that in Brazil?
Keep it short and to the point. 0.06. What is the ratio of the Exports(as % of merchandise exports) in 1964 in Bolivia to that in Brazil?
Offer a very short reply. 0.03. What is the ratio of the Exports(as % of merchandise exports) in 1965 in Bolivia to that in Brazil?
Make the answer very short. 0.09. What is the difference between the highest and the second highest Exports(as % of merchandise exports) of 1962?
Give a very brief answer. 6.41. What is the difference between the highest and the second highest Exports(as % of merchandise exports) in 1963?
Offer a very short reply. 4.54. What is the difference between the highest and the second highest Exports(as % of merchandise exports) of 1964?
Offer a very short reply. 2.33. What is the difference between the highest and the second highest Exports(as % of merchandise exports) in 1965?
Your answer should be very brief. 0.91. What is the difference between the highest and the lowest Exports(as % of merchandise exports) in 1962?
Keep it short and to the point. 22.21. What is the difference between the highest and the lowest Exports(as % of merchandise exports) in 1963?
Keep it short and to the point. 19.58. What is the difference between the highest and the lowest Exports(as % of merchandise exports) of 1964?
Keep it short and to the point. 16.95. What is the difference between the highest and the lowest Exports(as % of merchandise exports) in 1965?
Ensure brevity in your answer.  13.92. 